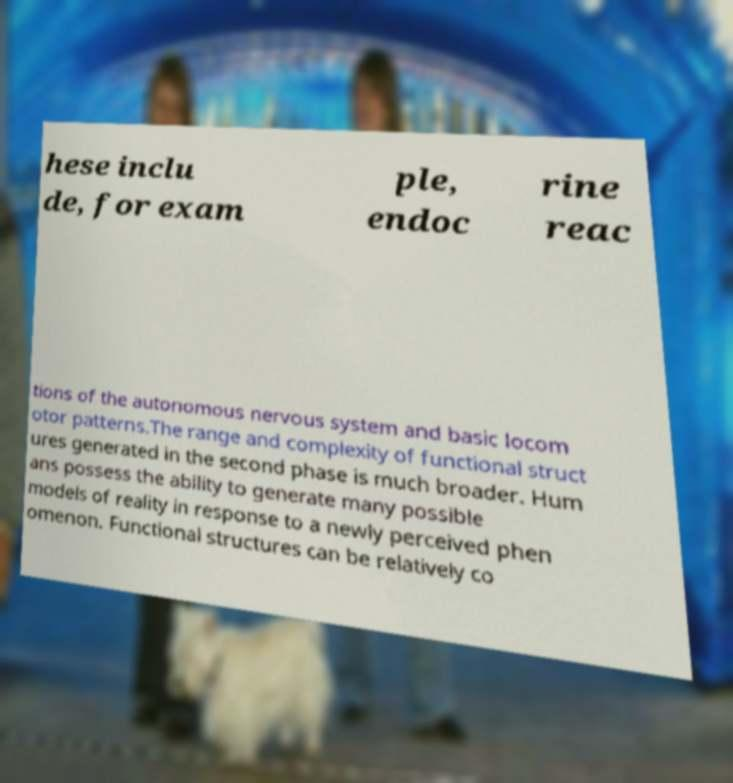For documentation purposes, I need the text within this image transcribed. Could you provide that? hese inclu de, for exam ple, endoc rine reac tions of the autonomous nervous system and basic locom otor patterns.The range and complexity of functional struct ures generated in the second phase is much broader. Hum ans possess the ability to generate many possible models of reality in response to a newly perceived phen omenon. Functional structures can be relatively co 